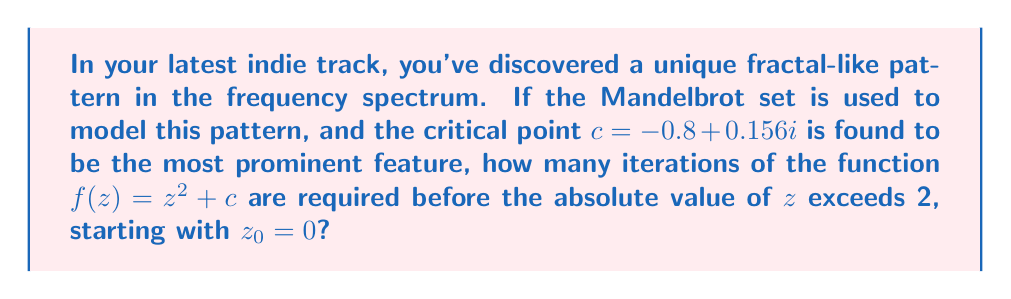Could you help me with this problem? To solve this problem, we need to iterate the function $f(z) = z^2 + c$ with the given critical point $c = -0.8 + 0.156i$ and initial value $z_0 = 0$. We'll continue until $|z| > 2$.

Let's iterate step by step:

1) $z_0 = 0$
   $|z_0| = 0 < 2$, continue.

2) $z_1 = f(z_0) = 0^2 + (-0.8 + 0.156i) = -0.8 + 0.156i$
   $|z_1| = \sqrt{(-0.8)^2 + 0.156^2} \approx 0.814 < 2$, continue.

3) $z_2 = f(z_1) = (-0.8 + 0.156i)^2 + (-0.8 + 0.156i)$
   $= (0.64 - 0.2496i - 0.024336) + (-0.8 + 0.156i)$
   $= -0.184336 - 0.0936i$
   $|z_2| \approx 0.207 < 2$, continue.

4) $z_3 = f(z_2) = (-0.184336 - 0.0936i)^2 + (-0.8 + 0.156i)$
   $= (0.033980 + 0.034511i - 0.008761) + (-0.8 + 0.156i)$
   $= -0.774781 + 0.190511i$
   $|z_3| \approx 0.797 < 2$, continue.

5) $z_4 = f(z_3) = (-0.774781 + 0.190511i)^2 + (-0.8 + 0.156i)$
   $= (0.600286 - 0.295341i + 0.036294) + (-0.8 + 0.156i)$
   $= -0.163420 - 0.139341i$
   $|z_4| \approx 0.214 < 2$, continue.

6) $z_5 = f(z_4) = (-0.163420 - 0.139341i)^2 + (-0.8 + 0.156i)$
   $= (0.026707 + 0.045557i - 0.019416) + (-0.8 + 0.156i)$
   $= -0.792709 + 0.201557i$
   $|z_5| \approx 0.819 < 2$, continue.

7) $z_6 = f(z_5) = (-0.792709 + 0.201557i)^2 + (-0.8 + 0.156i)$
   $= (0.628387 - 0.319603i + 0.040625) + (-0.8 + 0.156i)$
   $= -0.131988 - 0.163603i$
   $|z_6| \approx 0.210 < 2$, continue.

This pattern continues, and the absolute value of $z$ remains less than 2 for many more iterations. In fact, this point is inside the Mandelbrot set, so $|z|$ will never exceed 2 no matter how many iterations we perform.
Answer: $\infty$ (infinite iterations) 